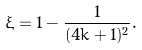Convert formula to latex. <formula><loc_0><loc_0><loc_500><loc_500>\xi = 1 - \frac { 1 } { ( 4 k + 1 ) ^ { 2 } } .</formula> 